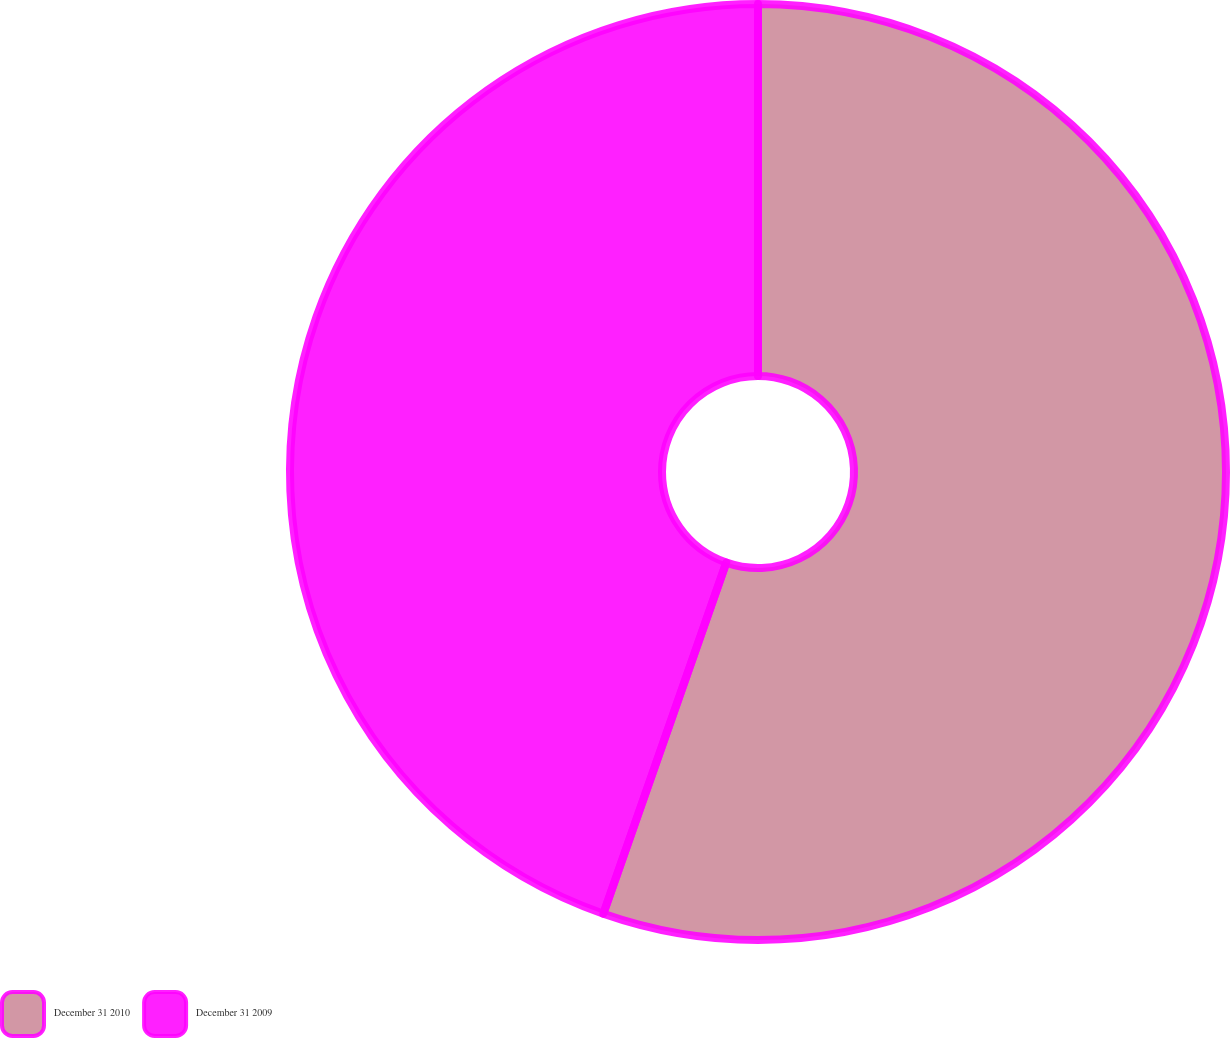<chart> <loc_0><loc_0><loc_500><loc_500><pie_chart><fcel>December 31 2010<fcel>December 31 2009<nl><fcel>55.36%<fcel>44.64%<nl></chart> 